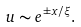<formula> <loc_0><loc_0><loc_500><loc_500>u \sim e ^ { \pm x / \xi } .</formula> 